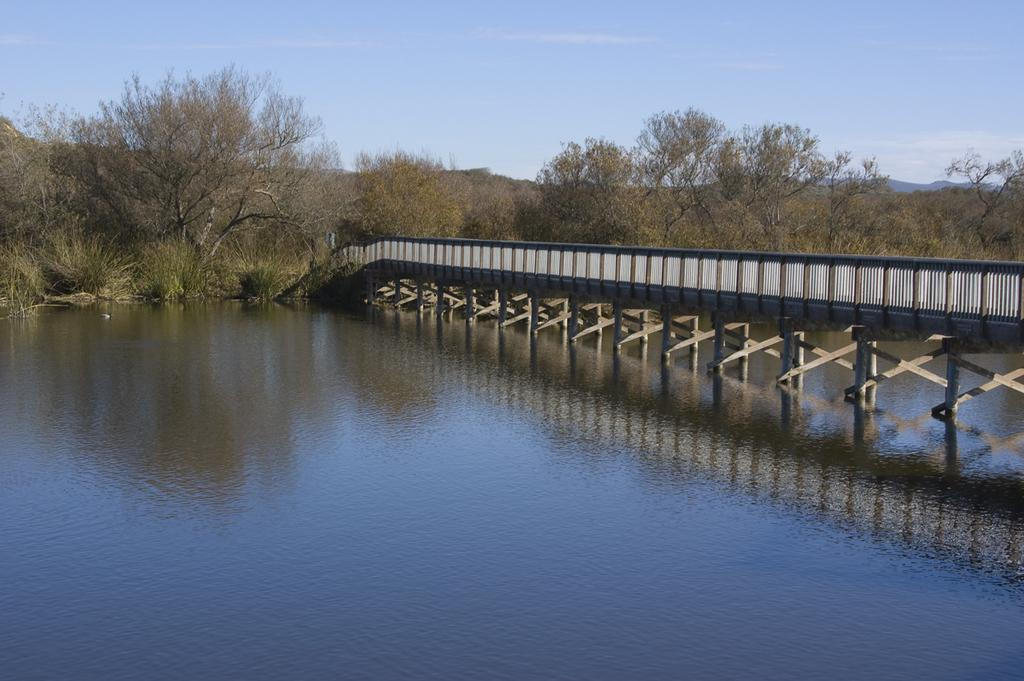What is the main feature of the image? The main feature of the image is water. What structure can be seen crossing over the water? There is a bridge present in the image. What type of natural environment is visible in the background of the image? There are many trees in the background of the image. What else can be seen in the background of the image? The sky is visible in the background of the image. How many goldfish are swimming in the water in the image? There are no goldfish present in the image; it only features water, a bridge, trees, and the sky. 